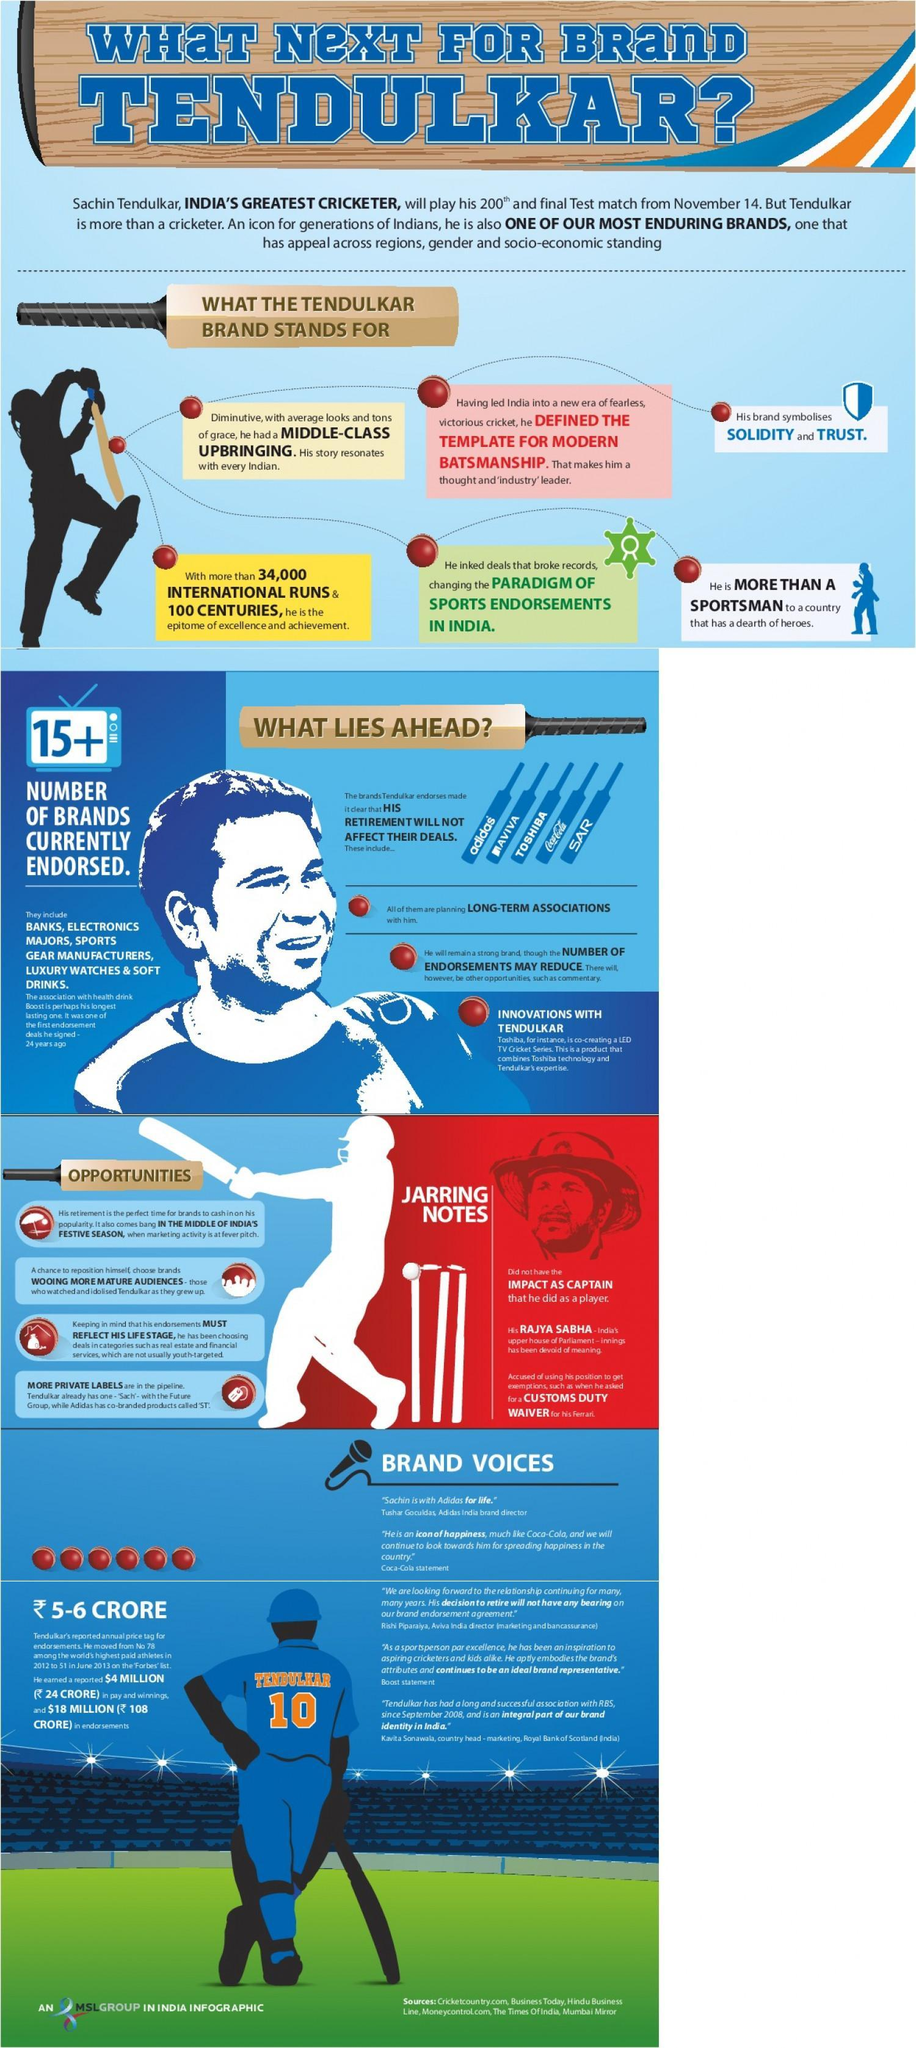How many brand names mentioned in this infographic?
Answer the question with a short phrase. 5 